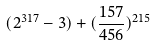<formula> <loc_0><loc_0><loc_500><loc_500>( 2 ^ { 3 1 7 } - 3 ) + ( \frac { 1 5 7 } { 4 5 6 } ) ^ { 2 1 5 }</formula> 